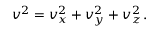Convert formula to latex. <formula><loc_0><loc_0><loc_500><loc_500>v ^ { 2 } = v _ { x } ^ { 2 } + v _ { y } ^ { 2 } + v _ { z } ^ { 2 } \, .</formula> 